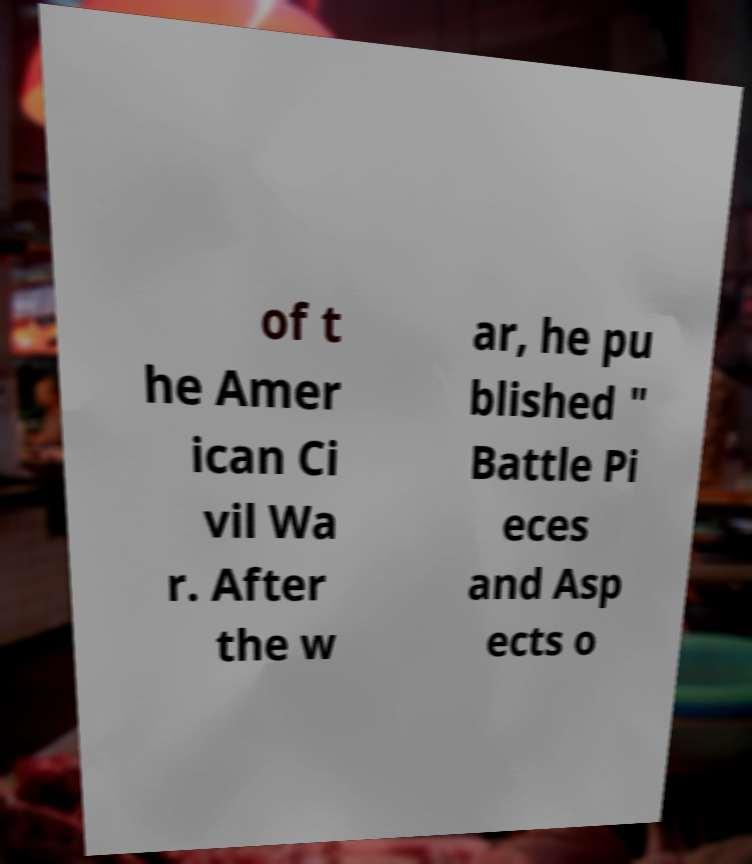Please read and relay the text visible in this image. What does it say? of t he Amer ican Ci vil Wa r. After the w ar, he pu blished " Battle Pi eces and Asp ects o 